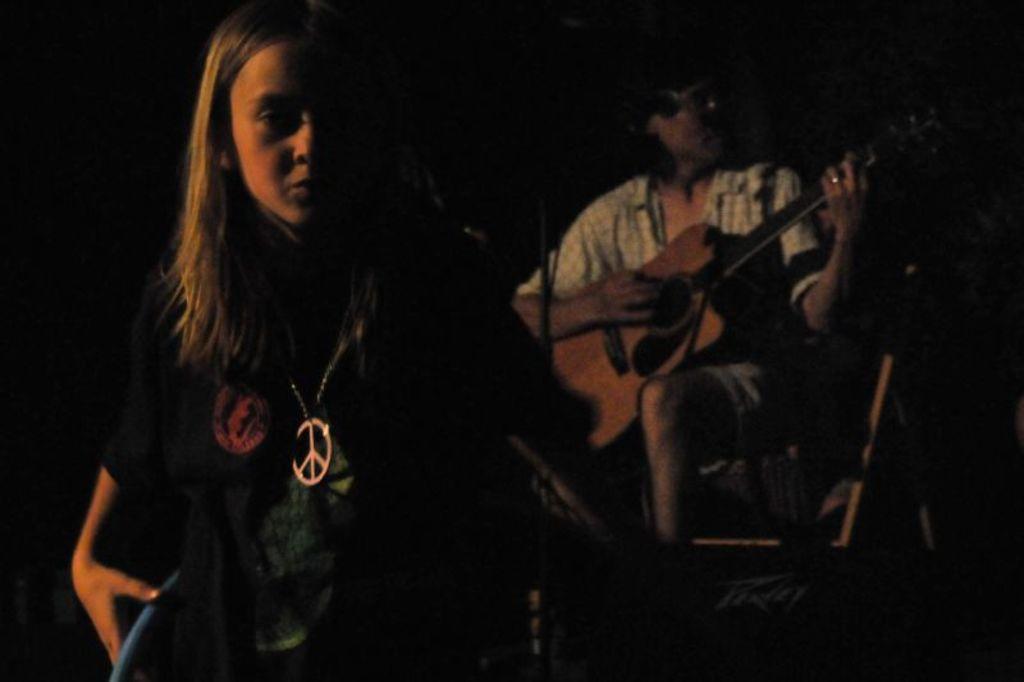How would you summarize this image in a sentence or two? The person wearing white shirt is sitting and playing guitar and there is another person standing in front of him. 